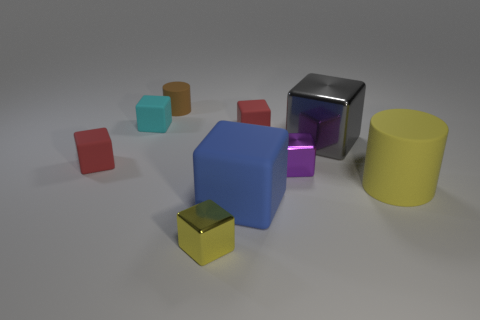Subtract all purple cubes. How many cubes are left? 6 Subtract all yellow cylinders. How many cylinders are left? 1 Add 1 yellow things. How many objects exist? 10 Subtract 1 cubes. How many cubes are left? 6 Subtract all red balls. How many red cubes are left? 2 Subtract all cylinders. How many objects are left? 7 Add 1 red matte things. How many red matte things are left? 3 Add 5 matte cylinders. How many matte cylinders exist? 7 Subtract 0 green spheres. How many objects are left? 9 Subtract all blue cylinders. Subtract all purple blocks. How many cylinders are left? 2 